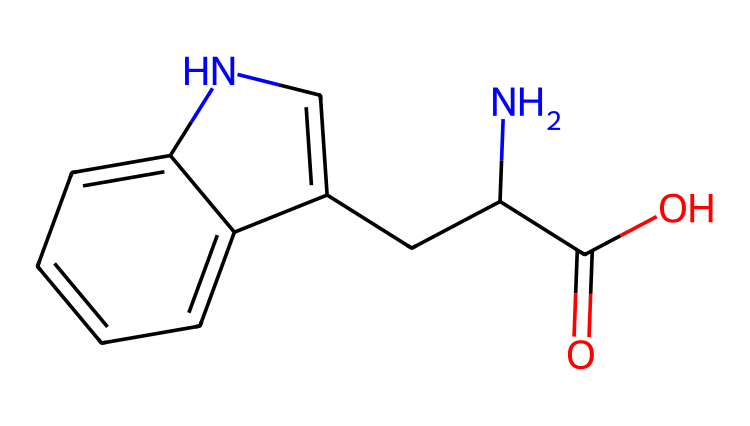What is the name of this chemical? The SMILES structure provided represents the amino acid tryptophan, which is an aromatic compound known for its influence on mood and productivity.
Answer: tryptophan How many nitrogen atoms are present in this structure? In the provided SMILES, there are two nitrogen atoms depicted. One is part of the indole ring structure and the other is linked to the amino group.
Answer: 2 What functional group is present in tryptophan? The chemical structure shows a carboxylic acid group (-COOH) at the end of the molecule, which is characteristic of amino acids.
Answer: carboxylic acid How many rings are in the chemical structure of tryptophan? Analyzing the SMILES, it shows one bicyclic system, which means there are two interconnected rings; one being the indole component of tryptophan.
Answer: 2 Is tryptophan a chiral compound? The structure contains a carbon atom bonded to four different substituents: an amino group, a carboxyl group, a hydrogen atom, and part of the indole ring, indicating chirality.
Answer: yes What type of compound is tryptophan in relation to its aromatic properties? The presence of a six-membered aromatic ring (the indole) in the structure categorizes tryptophan as an aromatic amino acid, which is distinct in its properties.
Answer: aromatic amino acid 